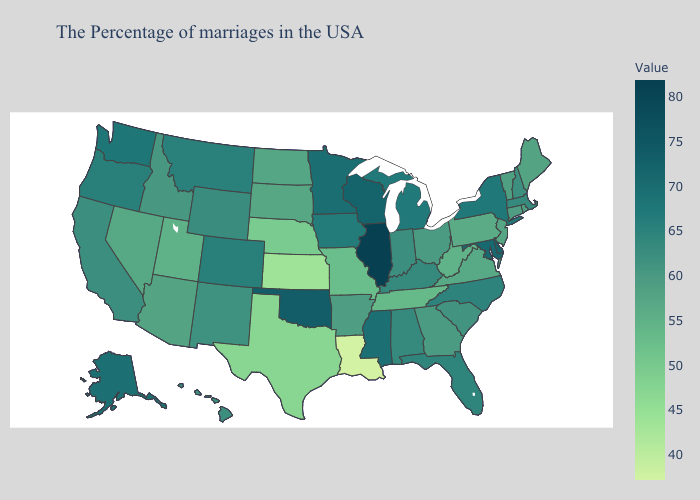Does Wisconsin have the highest value in the MidWest?
Write a very short answer. No. Among the states that border Illinois , which have the lowest value?
Be succinct. Missouri. Does Ohio have a higher value than Iowa?
Keep it brief. No. Which states have the lowest value in the West?
Quick response, please. Utah. 